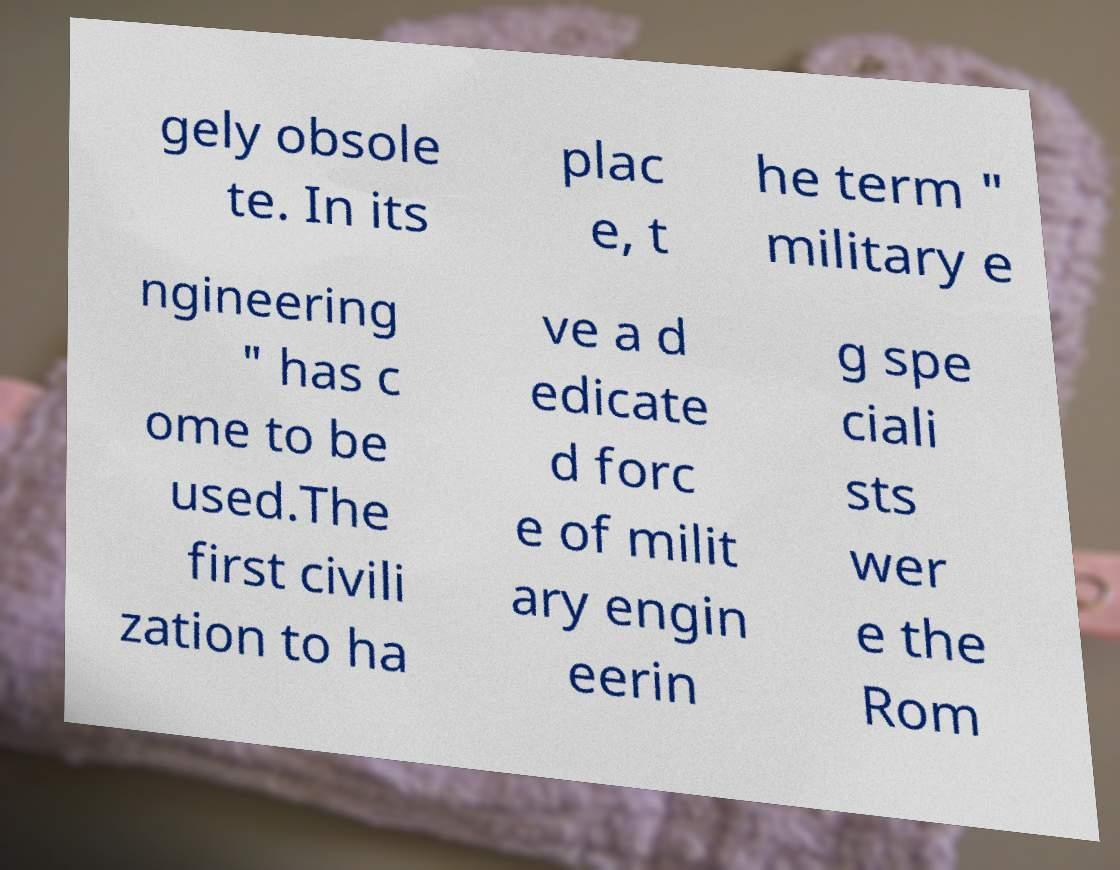Could you assist in decoding the text presented in this image and type it out clearly? gely obsole te. In its plac e, t he term " military e ngineering " has c ome to be used.The first civili zation to ha ve a d edicate d forc e of milit ary engin eerin g spe ciali sts wer e the Rom 